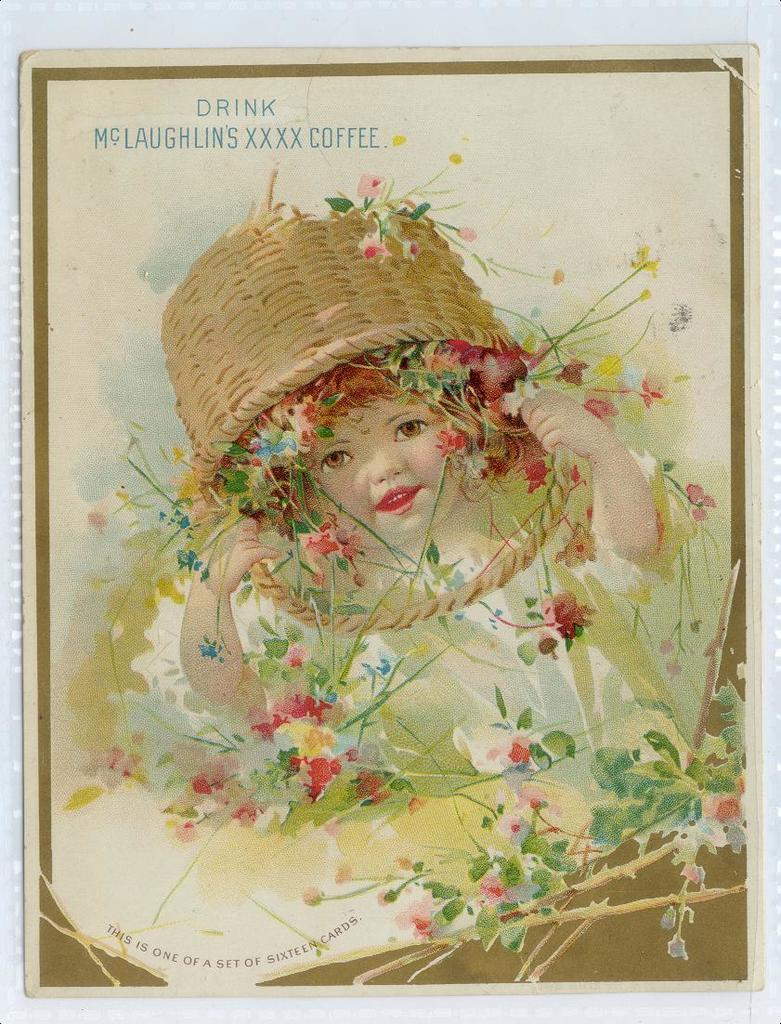In one or two sentences, can you explain what this image depicts? In this picture, we see an art of the baby. We see the flower basket is on her head. In the background, it is white in color. This picture might be a photo frame. 